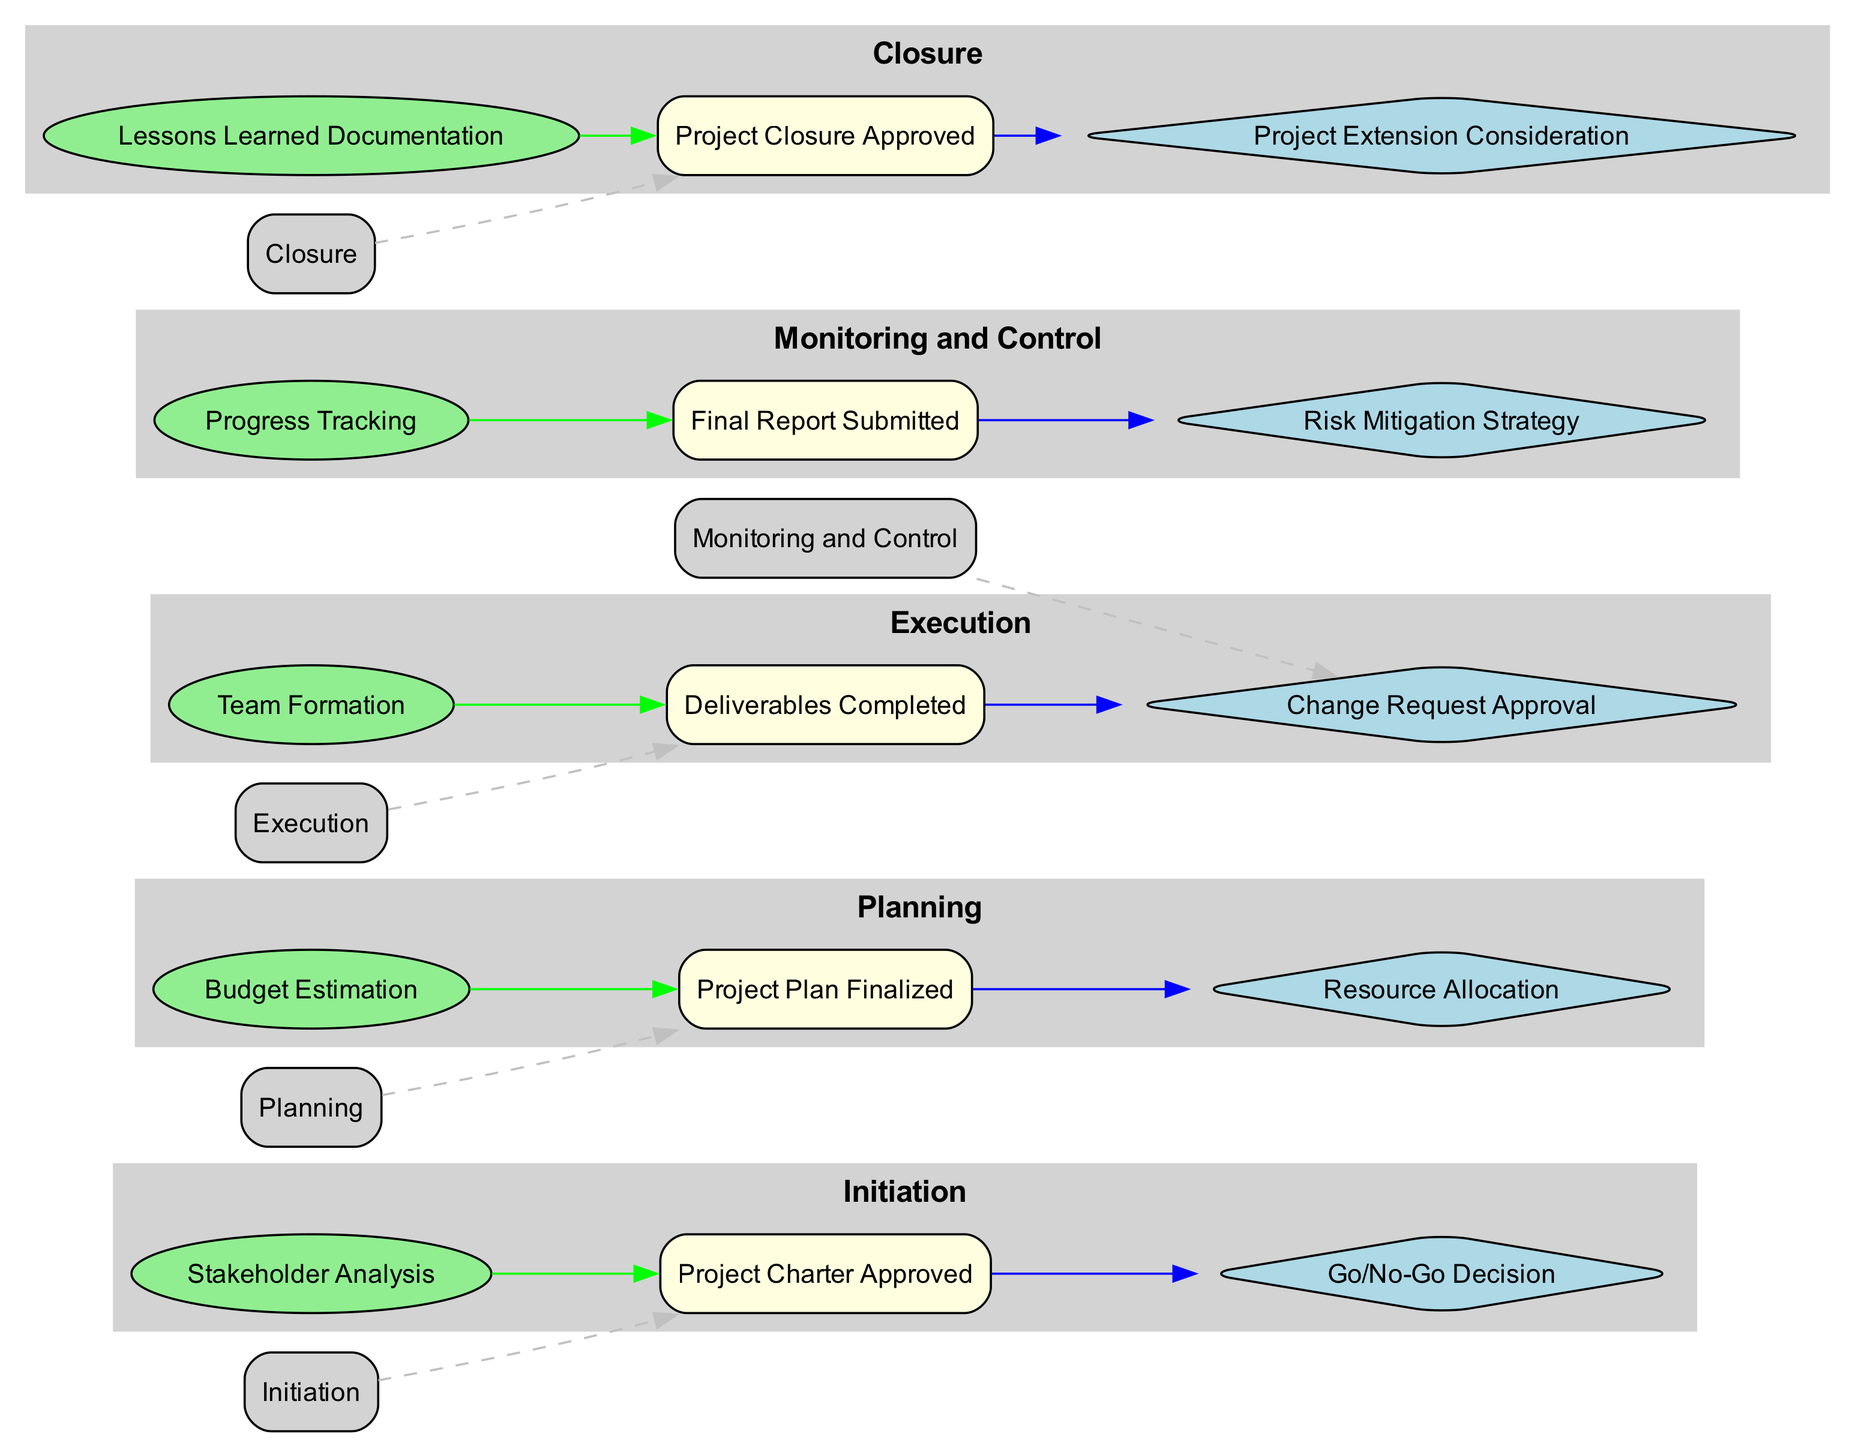What are the five stages in the project lifecycle? The diagram lists five stages: Initiation, Planning, Execution, Monitoring and Control, and Closure.
Answer: Initiation, Planning, Execution, Monitoring and Control, Closure What is the first milestone in the project lifecycle? The first milestone presented in the diagram is "Project Charter Approved," which is associated with the Initiation stage.
Answer: Project Charter Approved How many decision points are shown in the diagram? There are five decision points identified in the diagram, corresponding to each stage of the project lifecycle.
Answer: 5 What connects the Execution stage to the milestone associated with it? The Execution stage is connected to the milestone "Deliverables Completed" through a green edge, indicating the relationship between the stage and its milestone.
Answer: Deliverables Completed Which milestone is linked to the Monitoring and Control stage? The milestone linked to the Monitoring and Control stage is "Change Request Approval," according to the connections shown in the diagram.
Answer: Change Request Approval What is the key activity associated with the Planning stage? The key activity associated with the Planning stage is "Budget Estimation," as indicated in the diagram beneath the Planning stage.
Answer: Budget Estimation What decision point comes after the Monitoring and Control stage? The decision point that follows the Monitoring and Control stage is "Change Request Approval," which is reached as part of the control processes.
Answer: Change Request Approval Which two stages are connected by a dashed edge in the diagram? The dashed edge connects the Initiation stage to the milestone "Project Charter Approved," indicating a flow from the stage to the milestone.
Answer: Initiation and Project Charter Approved In which stage is "Lessons Learned Documentation" a key activity? "Lessons Learned Documentation" is the key activity in the Closure stage, as depicted in the diagram.
Answer: Closure What is the last milestone in the project lifecycle? The last milestone presented in the diagram is "Project Closure Approved," which is related to the Closure stage.
Answer: Project Closure Approved 